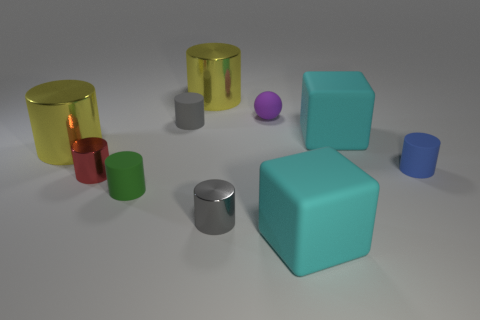Are there any matte things behind the small purple rubber sphere?
Your answer should be very brief. No. Do the small blue object and the cylinder that is behind the small ball have the same material?
Make the answer very short. No. There is a yellow shiny object to the left of the small green matte object; is its shape the same as the tiny gray rubber object?
Give a very brief answer. Yes. What number of red cubes are made of the same material as the purple object?
Make the answer very short. 0. What number of objects are either small gray cylinders in front of the tiny blue matte cylinder or large yellow metal cylinders?
Give a very brief answer. 3. The purple rubber object has what size?
Your answer should be compact. Small. There is a large yellow thing behind the purple thing that is to the right of the tiny gray shiny thing; what is its material?
Give a very brief answer. Metal. There is a metallic cylinder that is behind the matte ball; does it have the same size as the tiny red object?
Make the answer very short. No. Is there a tiny shiny thing of the same color as the matte sphere?
Your answer should be very brief. No. What number of objects are either big objects right of the green cylinder or tiny blue cylinders to the right of the red object?
Your answer should be very brief. 4. 